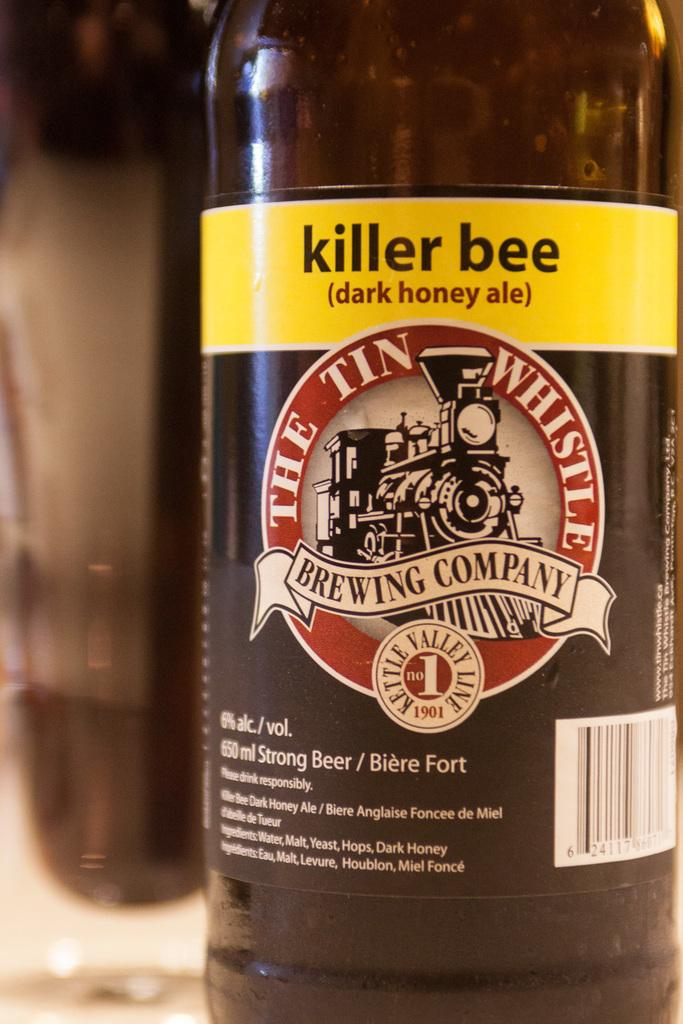<image>
Share a concise interpretation of the image provided. Bottle of alcohol with a yellow label which says KILLER BEE. 